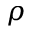Convert formula to latex. <formula><loc_0><loc_0><loc_500><loc_500>\rho</formula> 